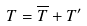<formula> <loc_0><loc_0><loc_500><loc_500>T = \overline { T } + T ^ { \prime }</formula> 